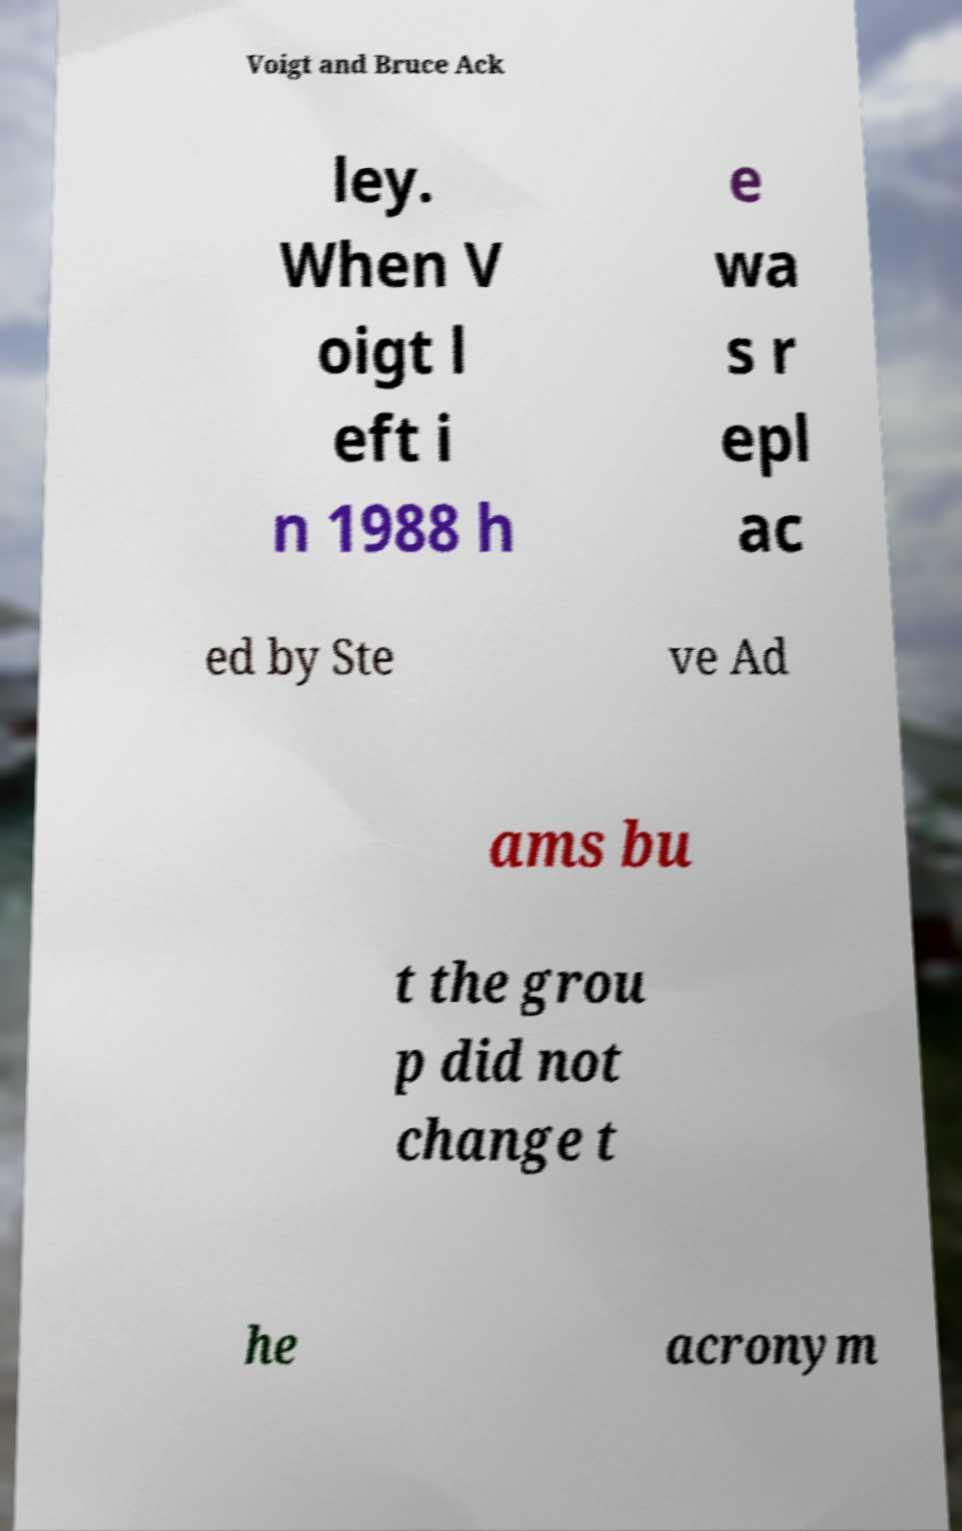I need the written content from this picture converted into text. Can you do that? Voigt and Bruce Ack ley. When V oigt l eft i n 1988 h e wa s r epl ac ed by Ste ve Ad ams bu t the grou p did not change t he acronym 